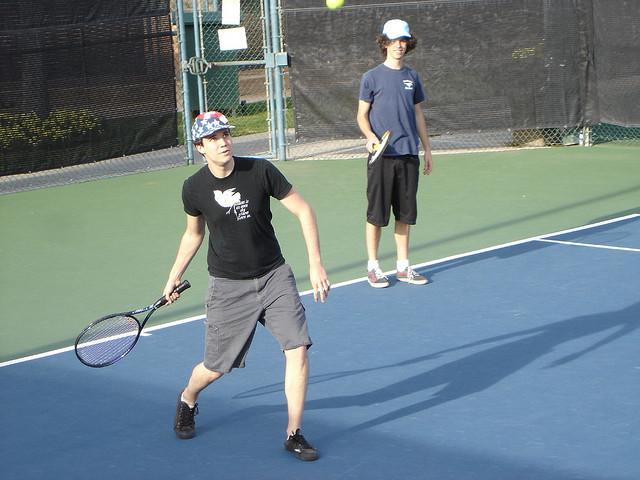What countries flag is on the man in the black shirts hat?

Choices:
A) finland
B) switzerland
C) germany
D) united states united states 